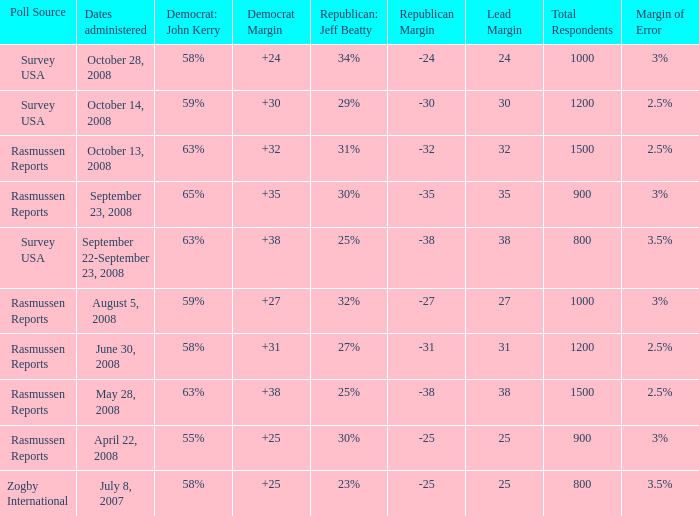What percent is the lead margin of 25 that Republican: Jeff Beatty has according to poll source Rasmussen Reports? 30%. 